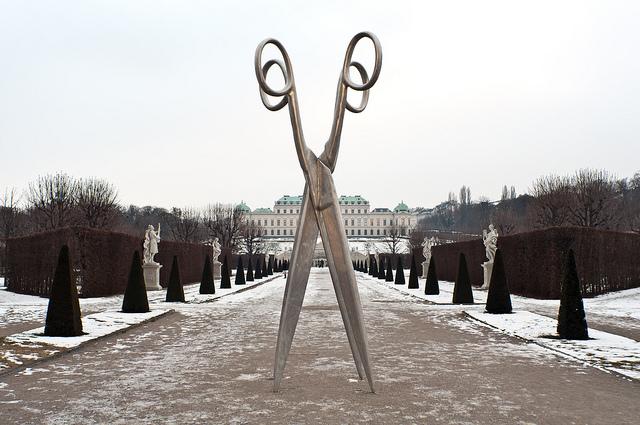Is this statue metal?
Concise answer only. Yes. Are these real scissors?
Answer briefly. No. Can this scissors cut paper?
Answer briefly. No. 